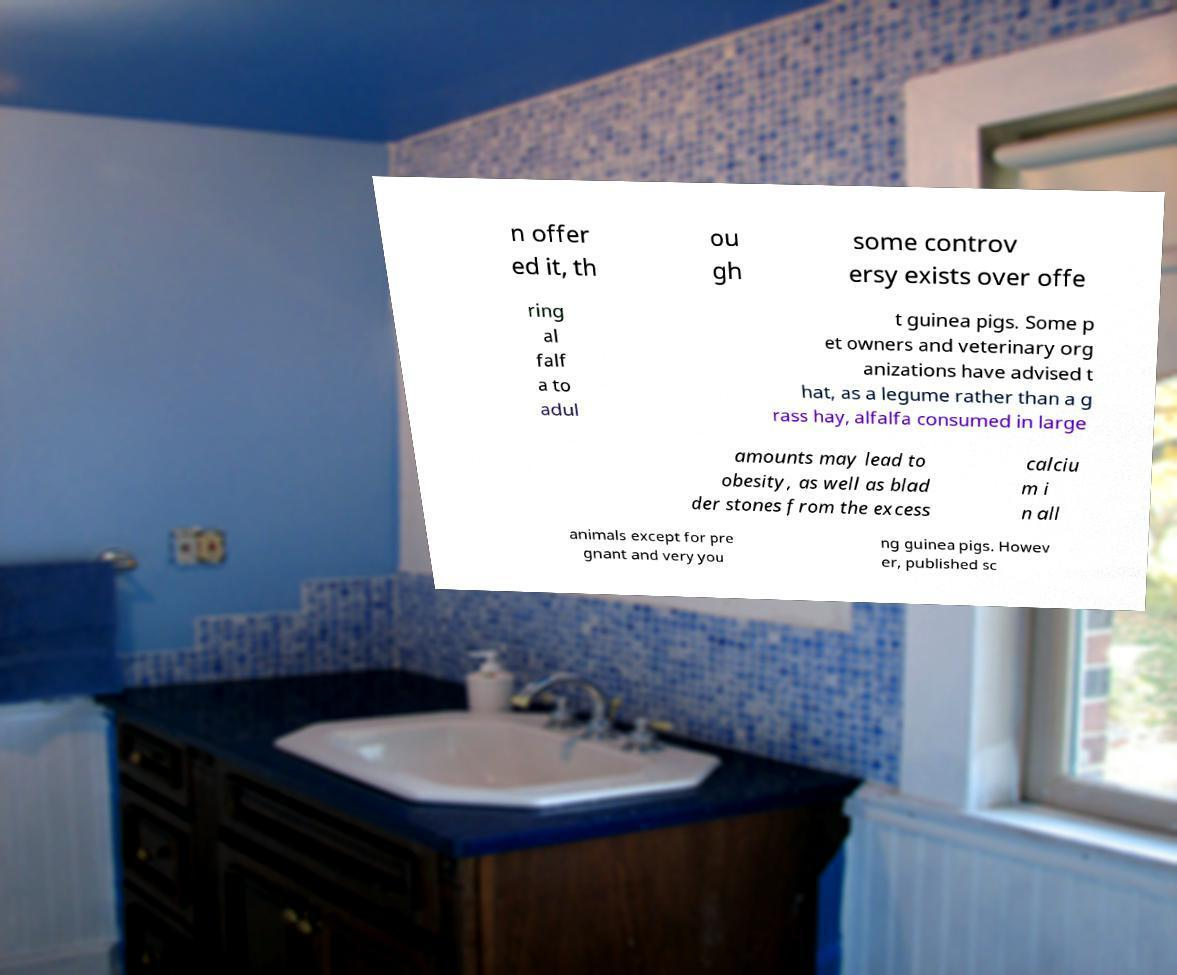Please read and relay the text visible in this image. What does it say? n offer ed it, th ou gh some controv ersy exists over offe ring al falf a to adul t guinea pigs. Some p et owners and veterinary org anizations have advised t hat, as a legume rather than a g rass hay, alfalfa consumed in large amounts may lead to obesity, as well as blad der stones from the excess calciu m i n all animals except for pre gnant and very you ng guinea pigs. Howev er, published sc 